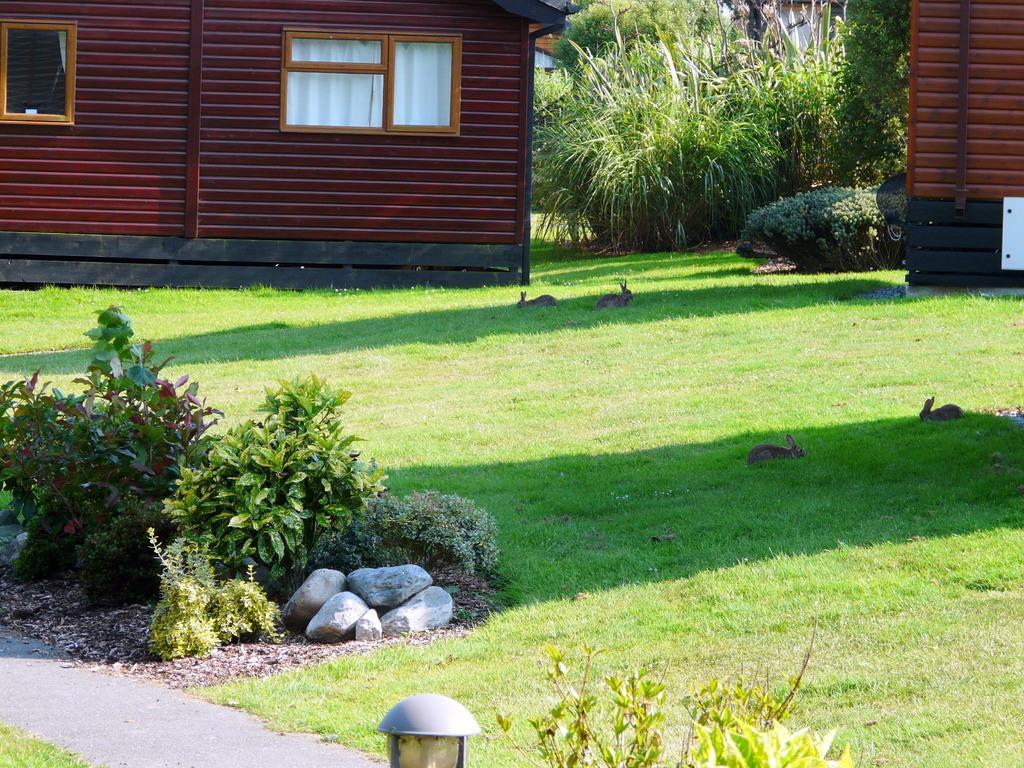Describe this image in one or two sentences. In this image in the background there are some houses and plants, at the bottom there is grass, rabbits, plants and some small stones and a light. 